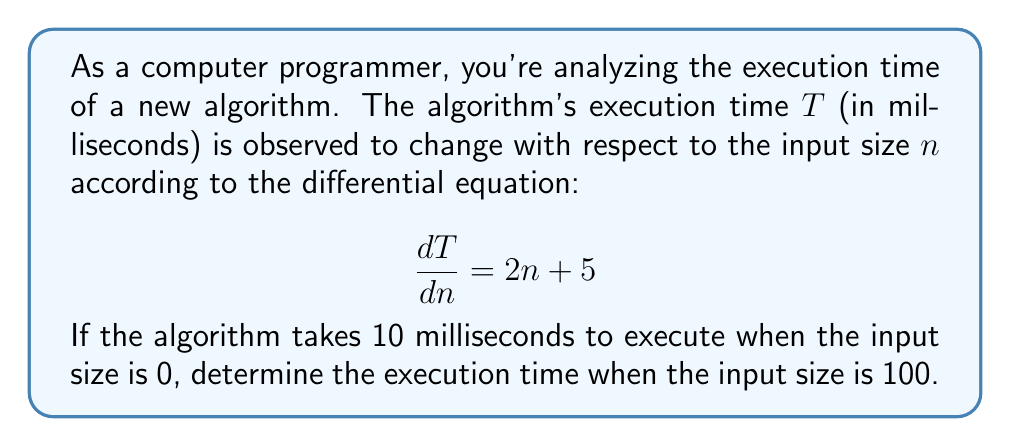Provide a solution to this math problem. To solve this problem, we need to integrate the given first-order differential equation and apply the initial condition. Let's break it down step by step:

1) We start with the differential equation:
   $$\frac{dT}{dn} = 2n + 5$$

2) To find $T$, we need to integrate both sides with respect to $n$:
   $$\int dT = \int (2n + 5) dn$$

3) Integrating the right side:
   $$T = n^2 + 5n + C$$
   where $C$ is the constant of integration.

4) Now we use the initial condition: when $n = 0$, $T = 10$. Let's substitute these values:
   $$10 = 0^2 + 5(0) + C$$
   $$10 = C$$

5) So our particular solution is:
   $$T = n^2 + 5n + 10$$

6) To find the execution time when the input size is 100, we substitute $n = 100$:
   $$T = 100^2 + 5(100) + 10$$
   $$T = 10000 + 500 + 10$$
   $$T = 10510$$

Thus, when the input size is 100, the execution time will be 10510 milliseconds.
Answer: $T = 10510$ milliseconds 